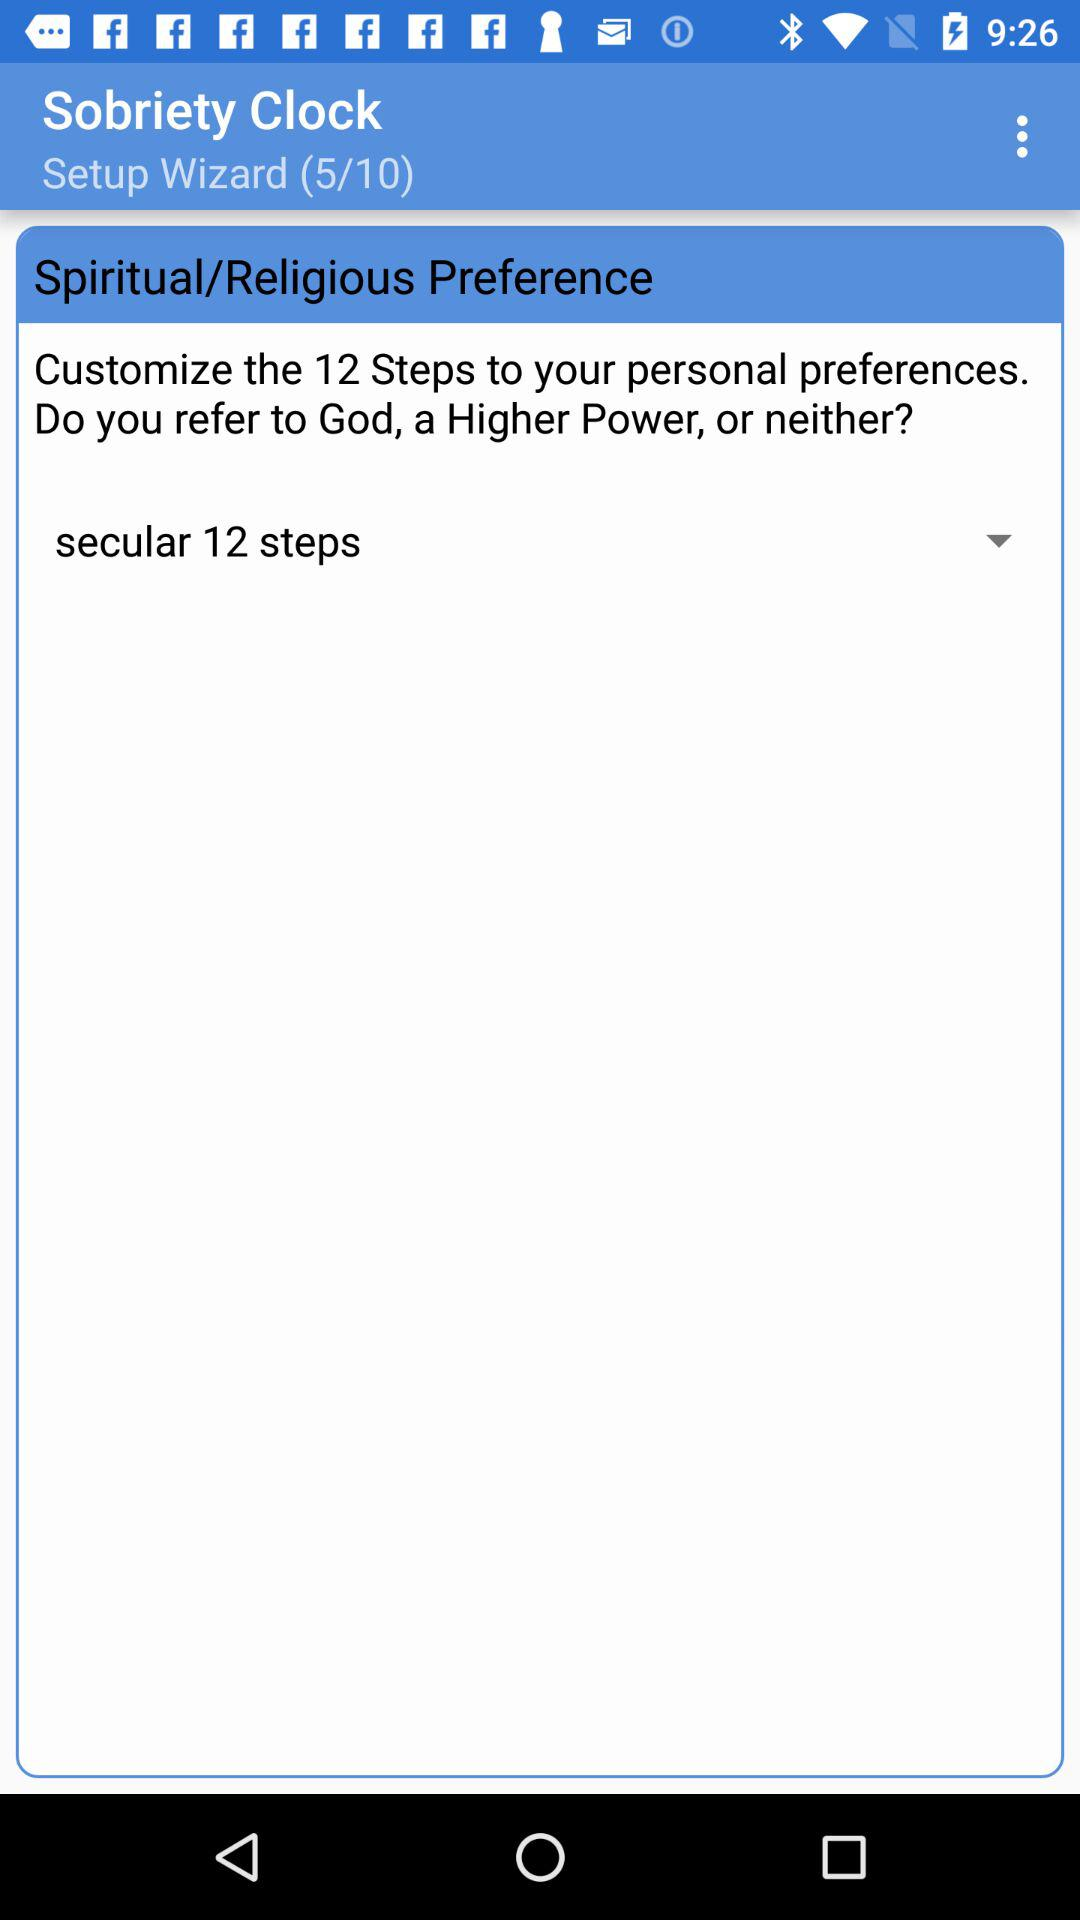How many steps are there in the 12 steps?
Answer the question using a single word or phrase. 12 